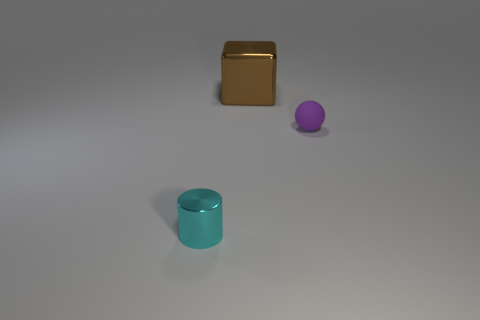Are there fewer rubber objects to the right of the small ball than cyan objects?
Provide a short and direct response. Yes. What shape is the object that is the same size as the sphere?
Offer a very short reply. Cylinder. What number of other objects are there of the same color as the small shiny thing?
Provide a succinct answer. 0. Is the cylinder the same size as the cube?
Ensure brevity in your answer.  No. How many objects are cyan cylinders or objects that are behind the small cylinder?
Your answer should be compact. 3. Is the number of purple matte balls behind the matte object less than the number of large objects that are in front of the cylinder?
Give a very brief answer. No. What number of other objects are the same material as the tiny ball?
Your answer should be very brief. 0. There is a tiny thing that is to the right of the small cyan cylinder; is its color the same as the big thing?
Provide a short and direct response. No. There is a thing to the right of the big metal thing; are there any tiny purple rubber spheres that are left of it?
Offer a very short reply. No. The object that is in front of the large thing and behind the small metal thing is made of what material?
Keep it short and to the point. Rubber. 